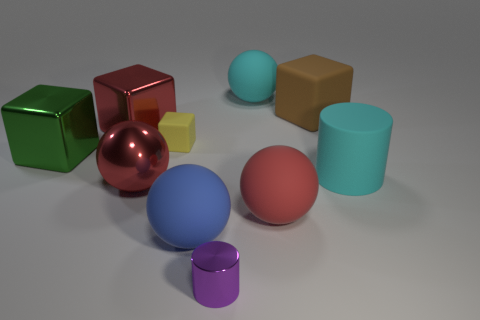Subtract all cyan balls. How many balls are left? 3 Subtract all blue balls. How many balls are left? 3 Subtract 3 spheres. How many spheres are left? 1 Subtract all blocks. How many objects are left? 6 Subtract all purple cylinders. How many green cubes are left? 1 Subtract all tiny yellow matte spheres. Subtract all blue rubber objects. How many objects are left? 9 Add 9 large red blocks. How many large red blocks are left? 10 Add 8 large gray shiny cubes. How many large gray shiny cubes exist? 8 Subtract 1 cyan spheres. How many objects are left? 9 Subtract all red spheres. Subtract all purple cylinders. How many spheres are left? 2 